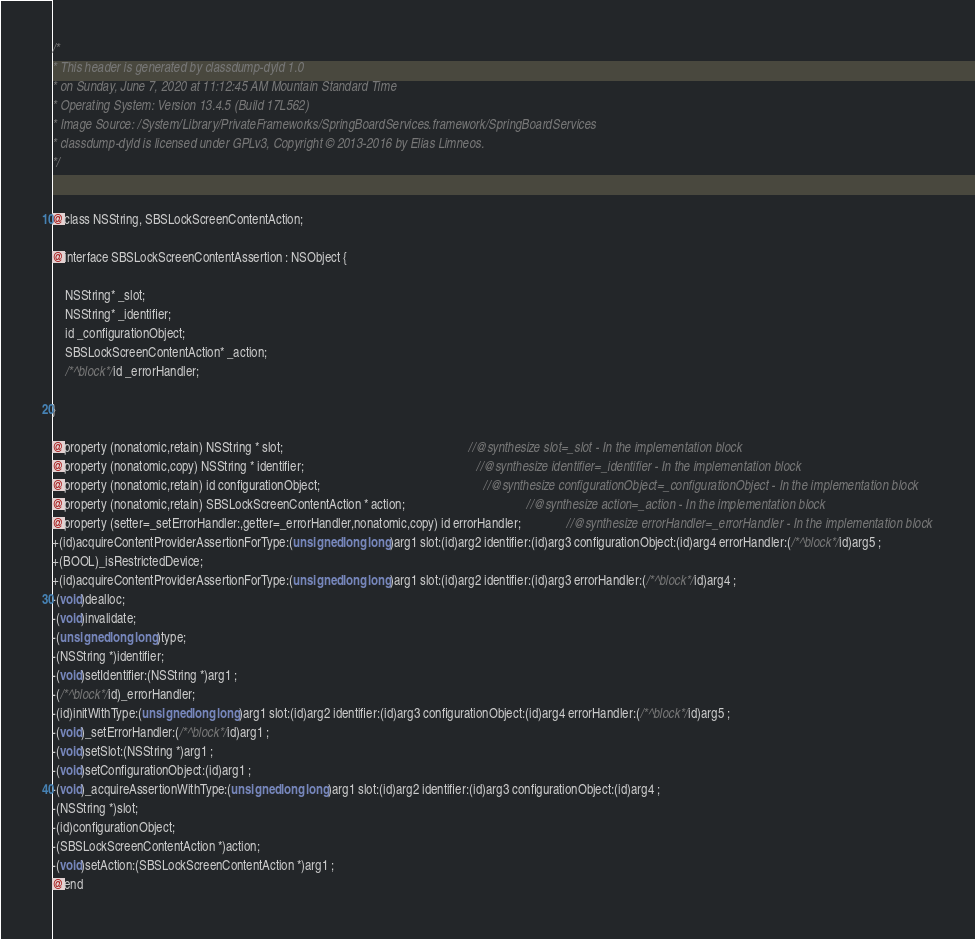<code> <loc_0><loc_0><loc_500><loc_500><_C_>/*
* This header is generated by classdump-dyld 1.0
* on Sunday, June 7, 2020 at 11:12:45 AM Mountain Standard Time
* Operating System: Version 13.4.5 (Build 17L562)
* Image Source: /System/Library/PrivateFrameworks/SpringBoardServices.framework/SpringBoardServices
* classdump-dyld is licensed under GPLv3, Copyright © 2013-2016 by Elias Limneos.
*/


@class NSString, SBSLockScreenContentAction;

@interface SBSLockScreenContentAssertion : NSObject {

	NSString* _slot;
	NSString* _identifier;
	id _configurationObject;
	SBSLockScreenContentAction* _action;
	/*^block*/id _errorHandler;

}

@property (nonatomic,retain) NSString * slot;                                                          //@synthesize slot=_slot - In the implementation block
@property (nonatomic,copy) NSString * identifier;                                                      //@synthesize identifier=_identifier - In the implementation block
@property (nonatomic,retain) id configurationObject;                                                   //@synthesize configurationObject=_configurationObject - In the implementation block
@property (nonatomic,retain) SBSLockScreenContentAction * action;                                      //@synthesize action=_action - In the implementation block
@property (setter=_setErrorHandler:,getter=_errorHandler,nonatomic,copy) id errorHandler;              //@synthesize errorHandler=_errorHandler - In the implementation block
+(id)acquireContentProviderAssertionForType:(unsigned long long)arg1 slot:(id)arg2 identifier:(id)arg3 configurationObject:(id)arg4 errorHandler:(/*^block*/id)arg5 ;
+(BOOL)_isRestrictedDevice;
+(id)acquireContentProviderAssertionForType:(unsigned long long)arg1 slot:(id)arg2 identifier:(id)arg3 errorHandler:(/*^block*/id)arg4 ;
-(void)dealloc;
-(void)invalidate;
-(unsigned long long)type;
-(NSString *)identifier;
-(void)setIdentifier:(NSString *)arg1 ;
-(/*^block*/id)_errorHandler;
-(id)initWithType:(unsigned long long)arg1 slot:(id)arg2 identifier:(id)arg3 configurationObject:(id)arg4 errorHandler:(/*^block*/id)arg5 ;
-(void)_setErrorHandler:(/*^block*/id)arg1 ;
-(void)setSlot:(NSString *)arg1 ;
-(void)setConfigurationObject:(id)arg1 ;
-(void)_acquireAssertionWithType:(unsigned long long)arg1 slot:(id)arg2 identifier:(id)arg3 configurationObject:(id)arg4 ;
-(NSString *)slot;
-(id)configurationObject;
-(SBSLockScreenContentAction *)action;
-(void)setAction:(SBSLockScreenContentAction *)arg1 ;
@end

</code> 